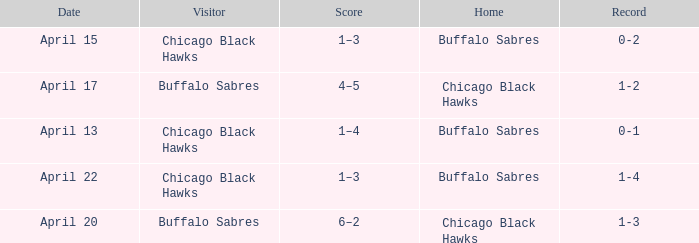Which Score has a Visitor of buffalo sabres and a Record of 1-3? 6–2. 